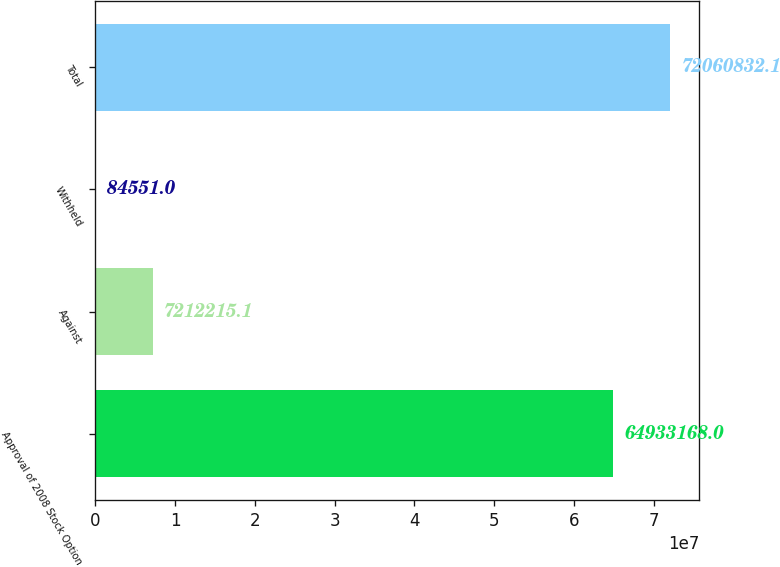<chart> <loc_0><loc_0><loc_500><loc_500><bar_chart><fcel>Approval of 2008 Stock Option<fcel>Against<fcel>Withheld<fcel>Total<nl><fcel>6.49332e+07<fcel>7.21222e+06<fcel>84551<fcel>7.20608e+07<nl></chart> 